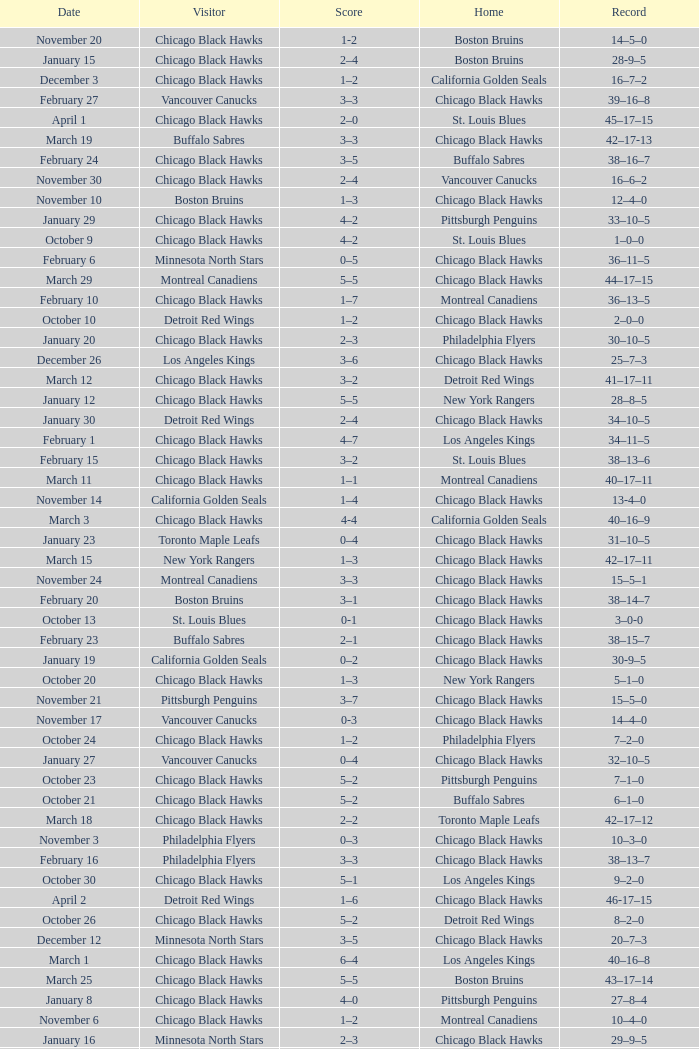What is the Record from February 10? 36–13–5. 